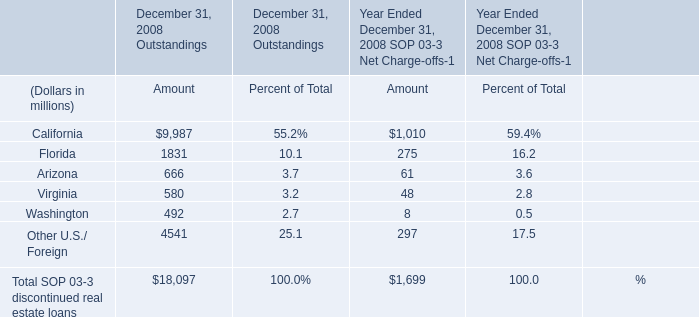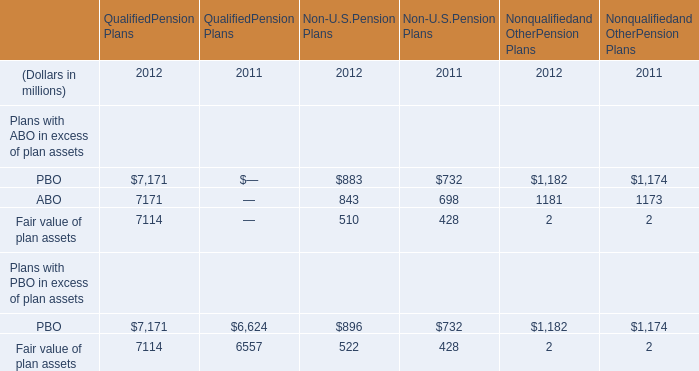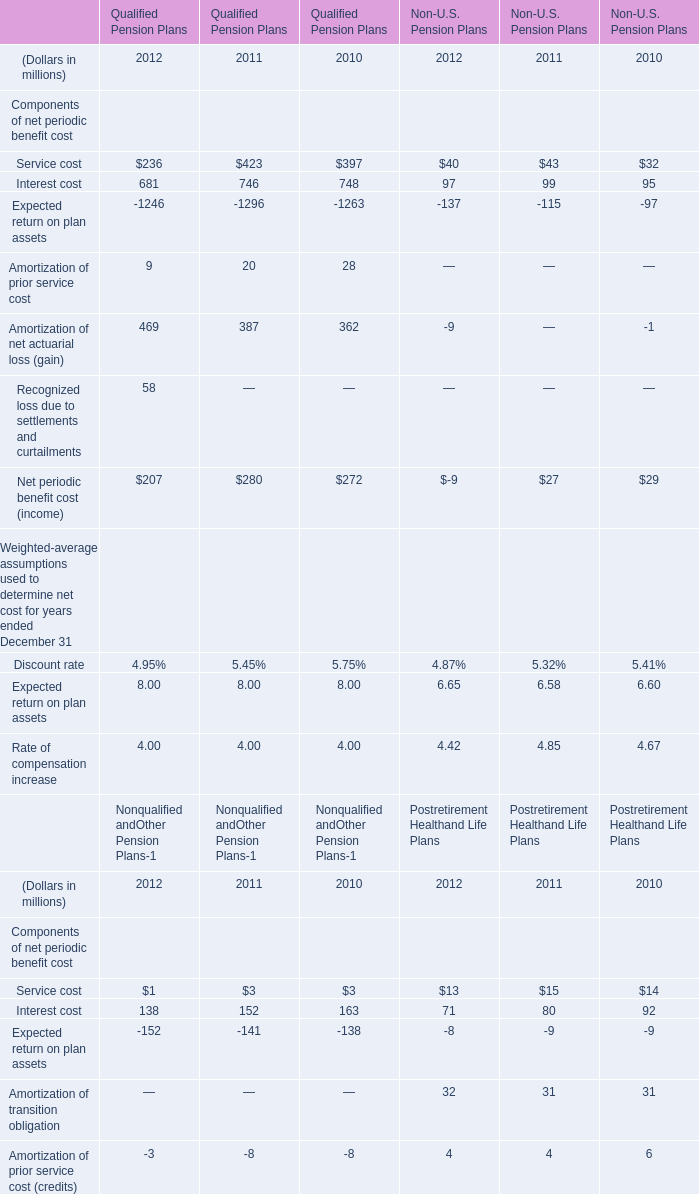What's the average of Service cost in 2012 and 2011 for Qualified Pension Plans? (in million) 
Computations: ((236 + 423) / 2)
Answer: 329.5. 